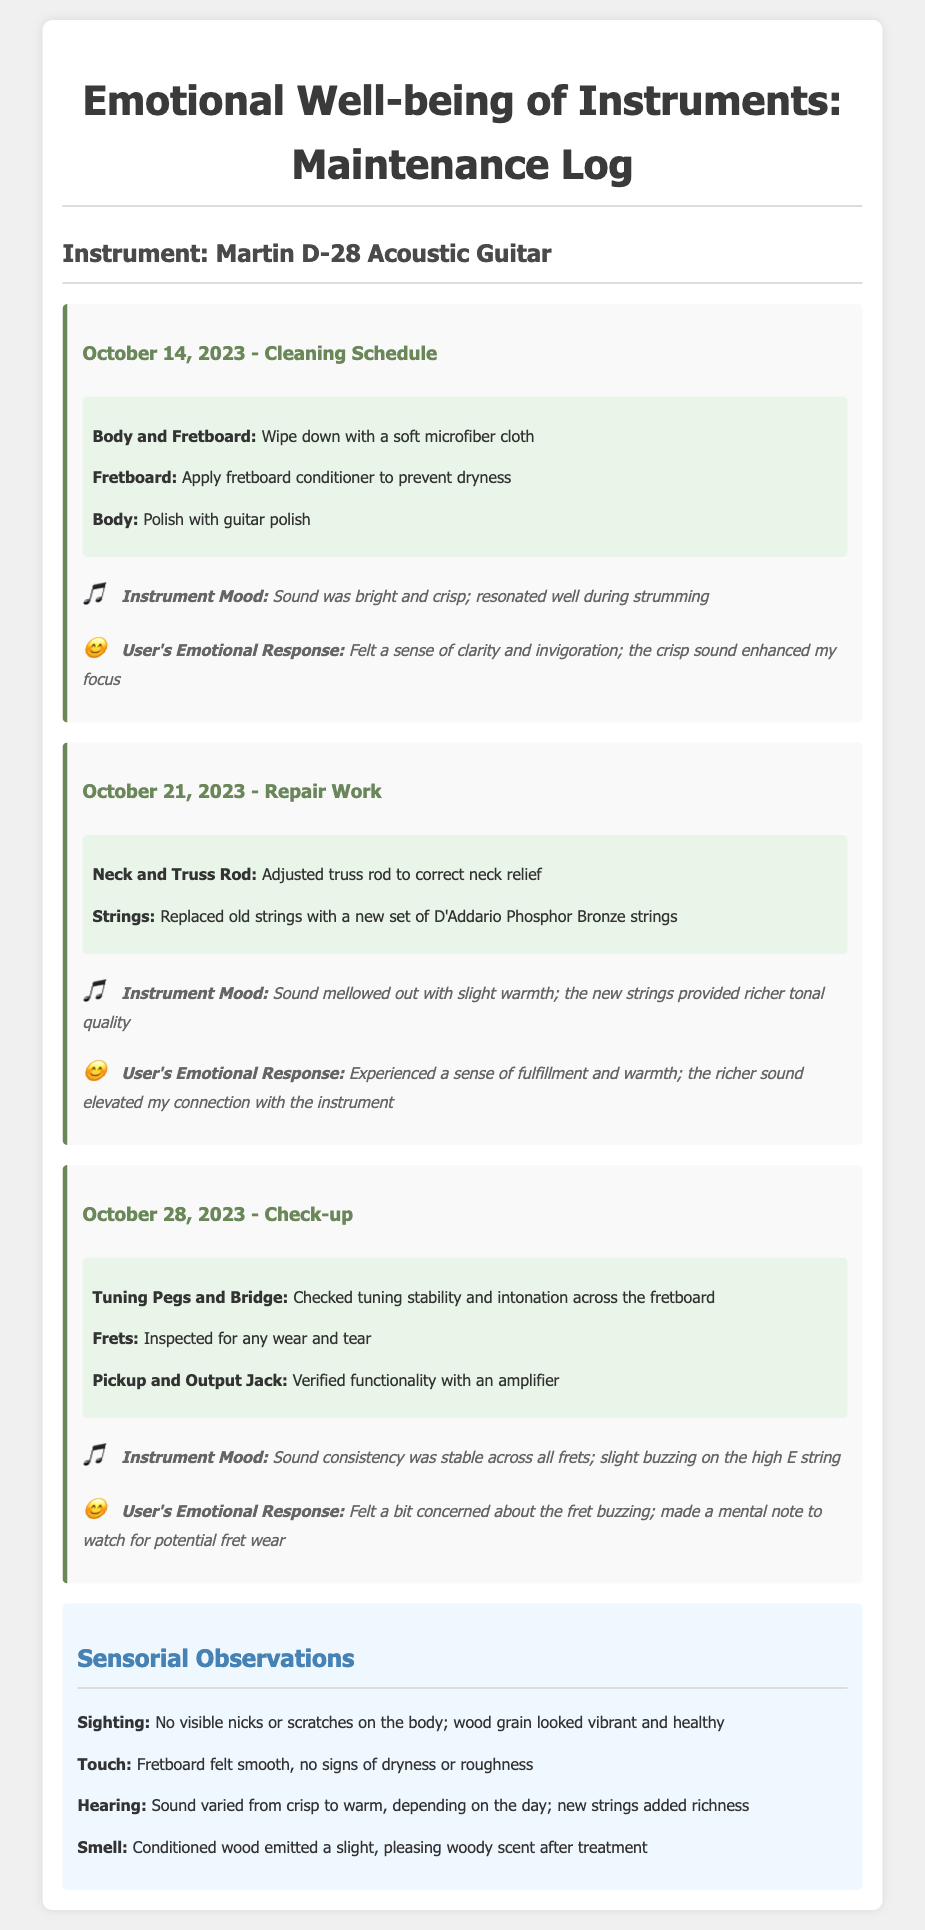What is the instrument being logged? The instrument being logged is explicitly stated at the beginning of the document.
Answer: Martin D-28 Acoustic Guitar What date was the cleaning schedule recorded? The specific date for the cleaning schedule is mentioned in the header of that section.
Answer: October 14, 2023 What emotional response did the user have during the repair work? The user's emotional response during the repair work is detailed in the observations for that entry.
Answer: Experienced a sense of fulfillment and warmth What task was performed on October 28, 2023? The tasks performed are listed within each entry, including the check-up on that date.
Answer: Checked tuning stability and intonation What mood did the instrument have on October 21, 2023? The instrument's mood is described under the observations in the repair work entry on that date.
Answer: Sound mellowed out with slight warmth What was the condition of the fretboard observed during cleaning? Observations include specific descriptions about the fretboard's condition after cleaning.
Answer: Fretboard felt smooth, no signs of dryness or roughness What scent was noted after conditioning the wood? The sensory observations describe the smell after treatment in the sensorium section.
Answer: Slight, pleasing woody scent Was there any buzzing noted during the check-up? The check-up observations specifically mention any issues found, including buzzing.
Answer: Slight buzzing on the high E string 